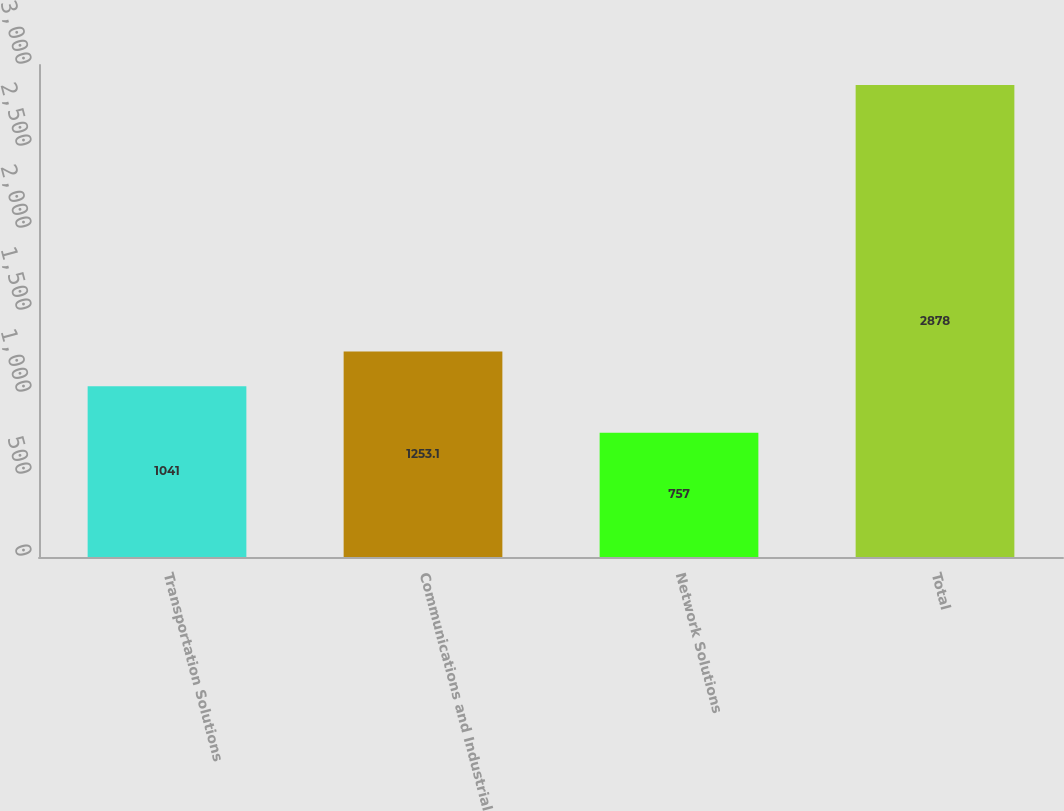Convert chart to OTSL. <chart><loc_0><loc_0><loc_500><loc_500><bar_chart><fcel>Transportation Solutions<fcel>Communications and Industrial<fcel>Network Solutions<fcel>Total<nl><fcel>1041<fcel>1253.1<fcel>757<fcel>2878<nl></chart> 